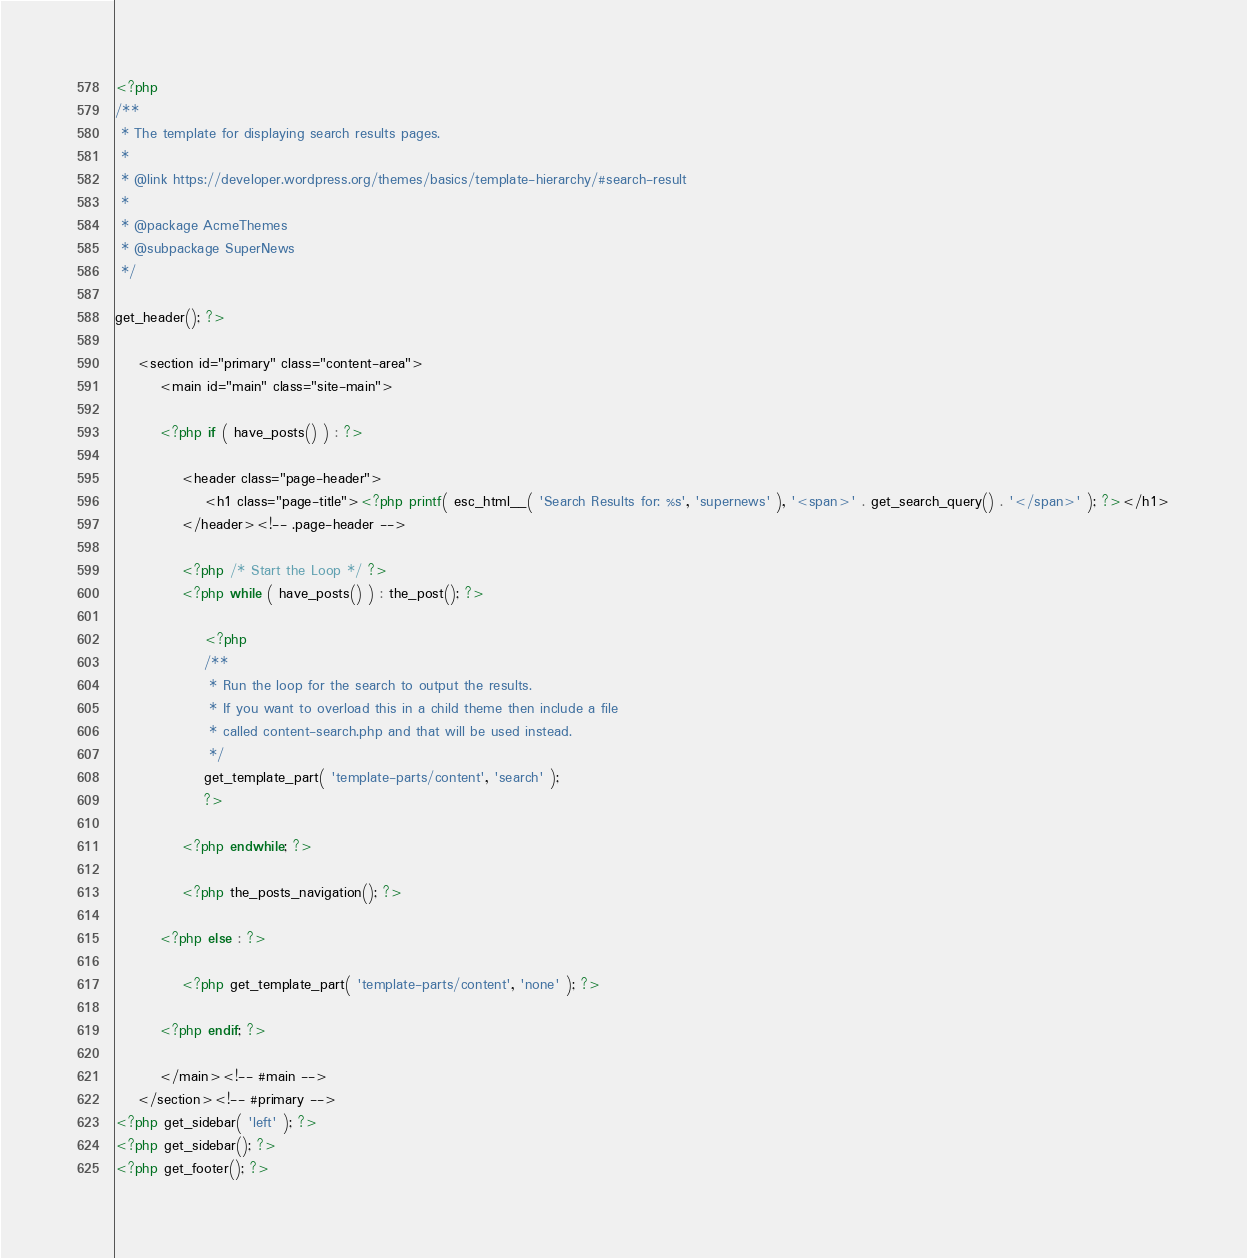<code> <loc_0><loc_0><loc_500><loc_500><_PHP_><?php
/**
 * The template for displaying search results pages.
 *
 * @link https://developer.wordpress.org/themes/basics/template-hierarchy/#search-result
 *
 * @package AcmeThemes
 * @subpackage SuperNews
 */

get_header(); ?>

	<section id="primary" class="content-area">
		<main id="main" class="site-main">

		<?php if ( have_posts() ) : ?>

			<header class="page-header">
				<h1 class="page-title"><?php printf( esc_html__( 'Search Results for: %s', 'supernews' ), '<span>' . get_search_query() . '</span>' ); ?></h1>
			</header><!-- .page-header -->

			<?php /* Start the Loop */ ?>
			<?php while ( have_posts() ) : the_post(); ?>

				<?php
				/**
				 * Run the loop for the search to output the results.
				 * If you want to overload this in a child theme then include a file
				 * called content-search.php and that will be used instead.
				 */
				get_template_part( 'template-parts/content', 'search' );
				?>

			<?php endwhile; ?>

			<?php the_posts_navigation(); ?>

		<?php else : ?>

			<?php get_template_part( 'template-parts/content', 'none' ); ?>

		<?php endif; ?>

		</main><!-- #main -->
	</section><!-- #primary -->
<?php get_sidebar( 'left' ); ?>
<?php get_sidebar(); ?>
<?php get_footer(); ?>
</code> 